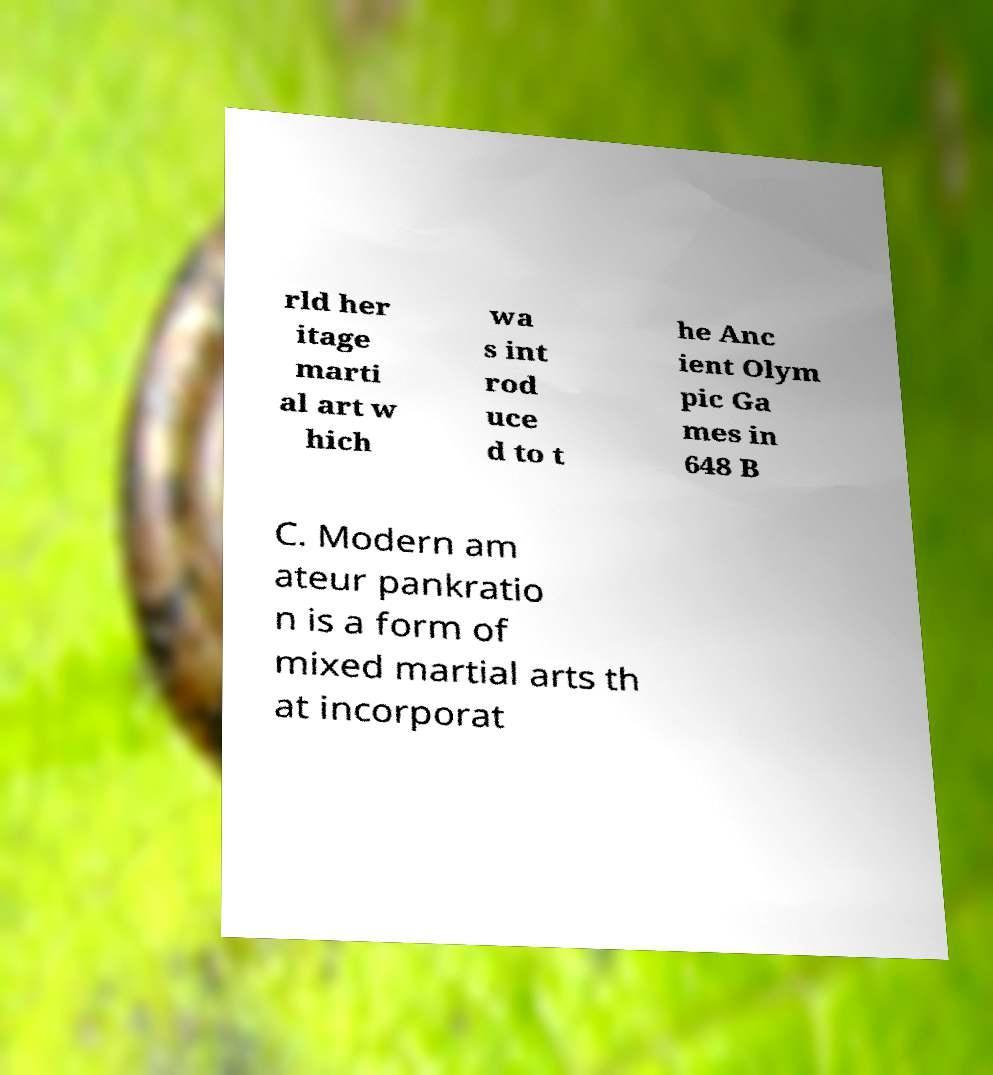Could you extract and type out the text from this image? rld her itage marti al art w hich wa s int rod uce d to t he Anc ient Olym pic Ga mes in 648 B C. Modern am ateur pankratio n is a form of mixed martial arts th at incorporat 